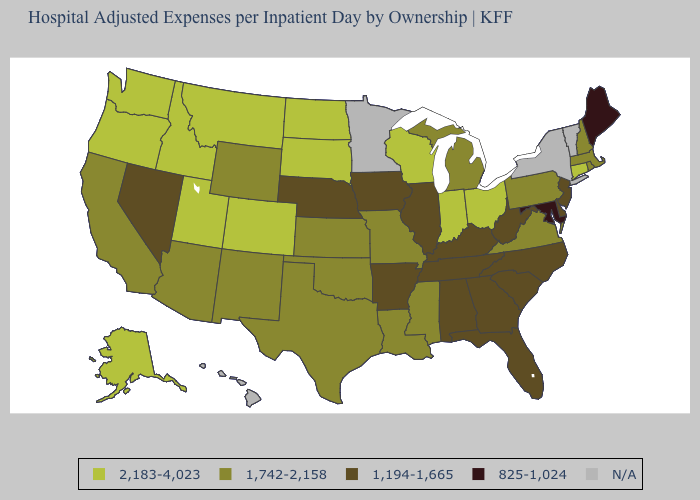What is the value of South Dakota?
Give a very brief answer. 2,183-4,023. Name the states that have a value in the range 1,194-1,665?
Give a very brief answer. Alabama, Arkansas, Delaware, Florida, Georgia, Illinois, Iowa, Kentucky, Nebraska, Nevada, New Jersey, North Carolina, South Carolina, Tennessee, West Virginia. What is the value of Nebraska?
Quick response, please. 1,194-1,665. What is the value of Kentucky?
Keep it brief. 1,194-1,665. What is the highest value in states that border Maryland?
Write a very short answer. 1,742-2,158. Which states have the lowest value in the USA?
Be succinct. Maine, Maryland. Name the states that have a value in the range 825-1,024?
Give a very brief answer. Maine, Maryland. Does Tennessee have the lowest value in the USA?
Be succinct. No. What is the value of Oklahoma?
Give a very brief answer. 1,742-2,158. What is the highest value in the USA?
Keep it brief. 2,183-4,023. What is the highest value in the South ?
Concise answer only. 1,742-2,158. What is the value of Louisiana?
Short answer required. 1,742-2,158. What is the lowest value in the South?
Answer briefly. 825-1,024. 